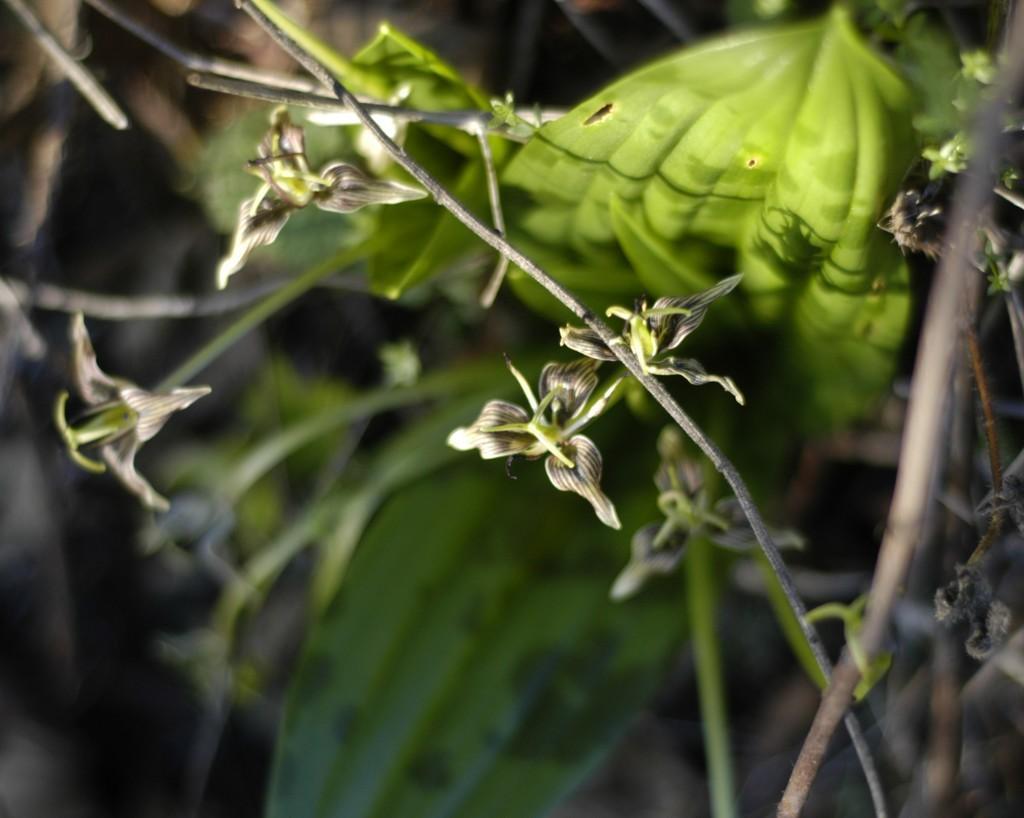In one or two sentences, can you explain what this image depicts? In this picture, we see the plants or trees, which have flowers. These flowers are in grey and green color. In the background, it is in green and black color. This picture is blurred in the background. 